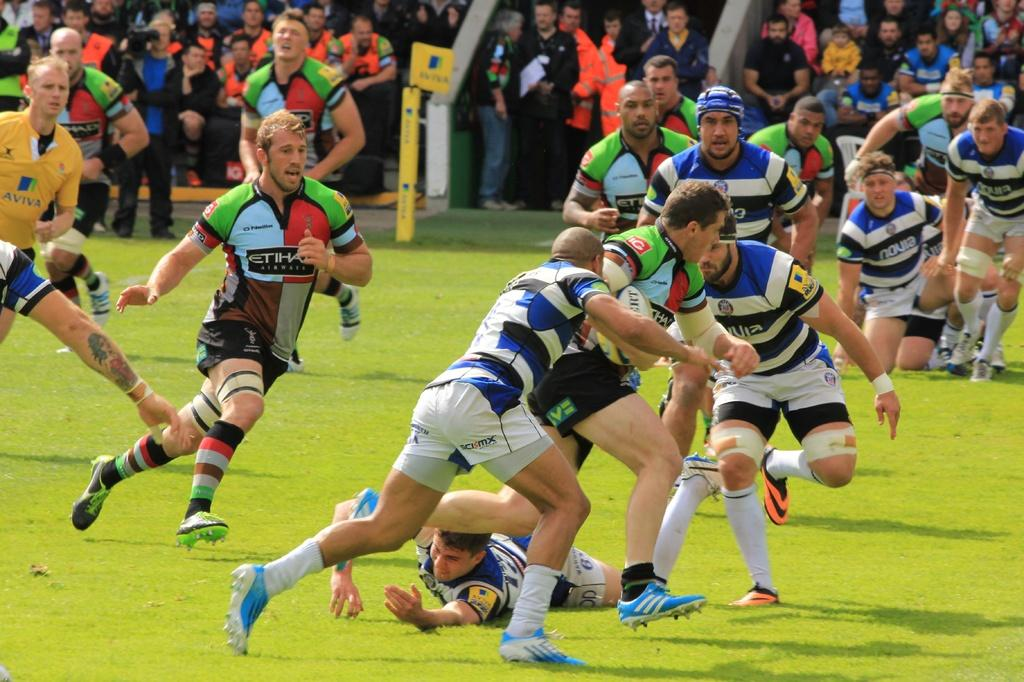<image>
Present a compact description of the photo's key features. Soccer players arre going at it, one of them wearing a striped shirt with Novia displayed 